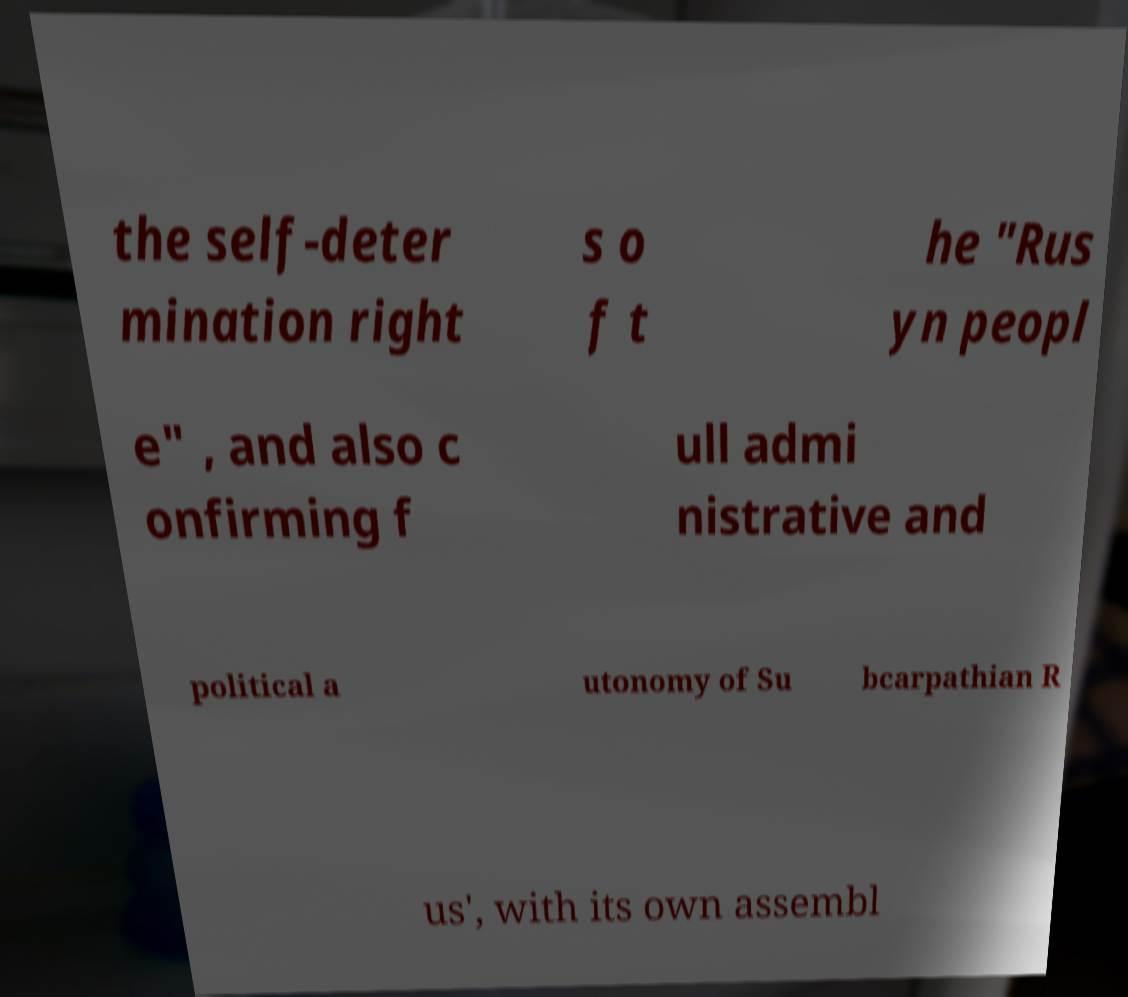Please read and relay the text visible in this image. What does it say? the self-deter mination right s o f t he "Rus yn peopl e" , and also c onfirming f ull admi nistrative and political a utonomy of Su bcarpathian R us', with its own assembl 